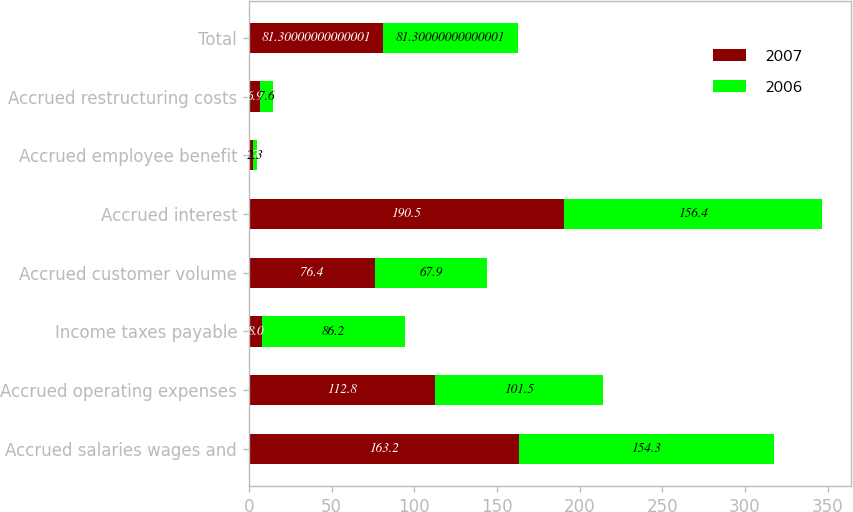Convert chart to OTSL. <chart><loc_0><loc_0><loc_500><loc_500><stacked_bar_chart><ecel><fcel>Accrued salaries wages and<fcel>Accrued operating expenses<fcel>Income taxes payable<fcel>Accrued customer volume<fcel>Accrued interest<fcel>Accrued employee benefit<fcel>Accrued restructuring costs<fcel>Total<nl><fcel>2007<fcel>163.2<fcel>112.8<fcel>8<fcel>76.4<fcel>190.5<fcel>2.7<fcel>6.9<fcel>81.3<nl><fcel>2006<fcel>154.3<fcel>101.5<fcel>86.2<fcel>67.9<fcel>156.4<fcel>2.3<fcel>7.6<fcel>81.3<nl></chart> 